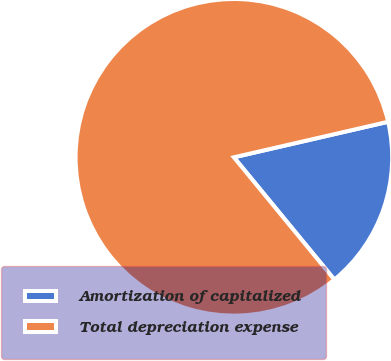Convert chart to OTSL. <chart><loc_0><loc_0><loc_500><loc_500><pie_chart><fcel>Amortization of capitalized<fcel>Total depreciation expense<nl><fcel>17.66%<fcel>82.34%<nl></chart> 